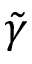<formula> <loc_0><loc_0><loc_500><loc_500>\tilde { \gamma }</formula> 